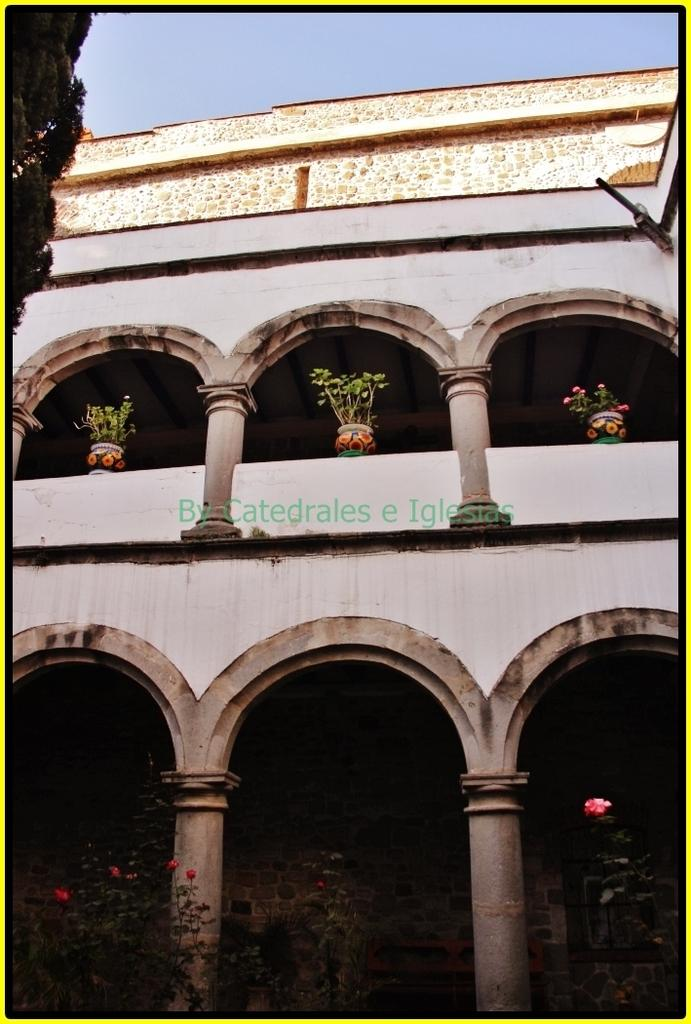What type of structure is present in the image? There is a building in the picture. What can be seen at the bottom of the image? There are plants visible at the bottom of the picture. What is visible at the top of the image? The sky is visible at the top of the picture. How many passengers are visible in the image? There are no passengers present in the image. What type of offer is being made in the image? There is no offer being made in the image. Can you see any toes in the image? There are no toes visible in the image. 